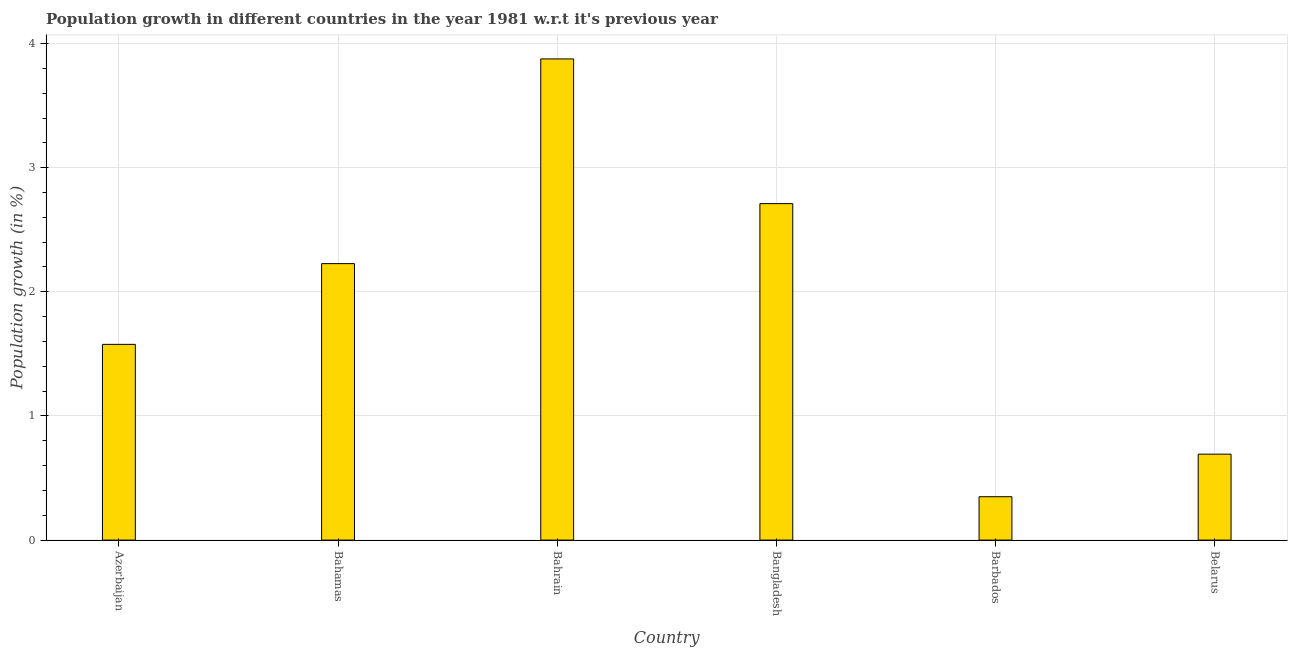Does the graph contain any zero values?
Your answer should be very brief. No. Does the graph contain grids?
Your answer should be very brief. Yes. What is the title of the graph?
Provide a succinct answer. Population growth in different countries in the year 1981 w.r.t it's previous year. What is the label or title of the Y-axis?
Provide a succinct answer. Population growth (in %). What is the population growth in Bahrain?
Your response must be concise. 3.88. Across all countries, what is the maximum population growth?
Provide a short and direct response. 3.88. Across all countries, what is the minimum population growth?
Provide a short and direct response. 0.35. In which country was the population growth maximum?
Your answer should be compact. Bahrain. In which country was the population growth minimum?
Offer a terse response. Barbados. What is the sum of the population growth?
Offer a terse response. 11.43. What is the difference between the population growth in Bahrain and Barbados?
Make the answer very short. 3.53. What is the average population growth per country?
Give a very brief answer. 1.91. What is the median population growth?
Offer a terse response. 1.9. What is the ratio of the population growth in Azerbaijan to that in Bahrain?
Ensure brevity in your answer.  0.41. What is the difference between the highest and the second highest population growth?
Provide a short and direct response. 1.17. Is the sum of the population growth in Azerbaijan and Bahrain greater than the maximum population growth across all countries?
Your answer should be very brief. Yes. What is the difference between the highest and the lowest population growth?
Your response must be concise. 3.53. Are all the bars in the graph horizontal?
Ensure brevity in your answer.  No. What is the Population growth (in %) in Azerbaijan?
Provide a succinct answer. 1.58. What is the Population growth (in %) in Bahamas?
Keep it short and to the point. 2.23. What is the Population growth (in %) of Bahrain?
Offer a terse response. 3.88. What is the Population growth (in %) in Bangladesh?
Keep it short and to the point. 2.71. What is the Population growth (in %) in Barbados?
Provide a short and direct response. 0.35. What is the Population growth (in %) in Belarus?
Provide a short and direct response. 0.69. What is the difference between the Population growth (in %) in Azerbaijan and Bahamas?
Keep it short and to the point. -0.65. What is the difference between the Population growth (in %) in Azerbaijan and Bahrain?
Your answer should be very brief. -2.3. What is the difference between the Population growth (in %) in Azerbaijan and Bangladesh?
Provide a succinct answer. -1.13. What is the difference between the Population growth (in %) in Azerbaijan and Barbados?
Keep it short and to the point. 1.23. What is the difference between the Population growth (in %) in Azerbaijan and Belarus?
Make the answer very short. 0.88. What is the difference between the Population growth (in %) in Bahamas and Bahrain?
Your response must be concise. -1.65. What is the difference between the Population growth (in %) in Bahamas and Bangladesh?
Offer a very short reply. -0.48. What is the difference between the Population growth (in %) in Bahamas and Barbados?
Offer a very short reply. 1.88. What is the difference between the Population growth (in %) in Bahamas and Belarus?
Make the answer very short. 1.53. What is the difference between the Population growth (in %) in Bahrain and Bangladesh?
Keep it short and to the point. 1.17. What is the difference between the Population growth (in %) in Bahrain and Barbados?
Offer a terse response. 3.53. What is the difference between the Population growth (in %) in Bahrain and Belarus?
Make the answer very short. 3.18. What is the difference between the Population growth (in %) in Bangladesh and Barbados?
Your answer should be compact. 2.36. What is the difference between the Population growth (in %) in Bangladesh and Belarus?
Provide a short and direct response. 2.02. What is the difference between the Population growth (in %) in Barbados and Belarus?
Ensure brevity in your answer.  -0.34. What is the ratio of the Population growth (in %) in Azerbaijan to that in Bahamas?
Give a very brief answer. 0.71. What is the ratio of the Population growth (in %) in Azerbaijan to that in Bahrain?
Make the answer very short. 0.41. What is the ratio of the Population growth (in %) in Azerbaijan to that in Bangladesh?
Make the answer very short. 0.58. What is the ratio of the Population growth (in %) in Azerbaijan to that in Barbados?
Keep it short and to the point. 4.51. What is the ratio of the Population growth (in %) in Azerbaijan to that in Belarus?
Ensure brevity in your answer.  2.28. What is the ratio of the Population growth (in %) in Bahamas to that in Bahrain?
Keep it short and to the point. 0.57. What is the ratio of the Population growth (in %) in Bahamas to that in Bangladesh?
Your answer should be compact. 0.82. What is the ratio of the Population growth (in %) in Bahamas to that in Barbados?
Provide a short and direct response. 6.37. What is the ratio of the Population growth (in %) in Bahamas to that in Belarus?
Offer a very short reply. 3.22. What is the ratio of the Population growth (in %) in Bahrain to that in Bangladesh?
Provide a succinct answer. 1.43. What is the ratio of the Population growth (in %) in Bahrain to that in Barbados?
Offer a very short reply. 11.09. What is the ratio of the Population growth (in %) in Bahrain to that in Belarus?
Provide a short and direct response. 5.6. What is the ratio of the Population growth (in %) in Bangladesh to that in Barbados?
Make the answer very short. 7.75. What is the ratio of the Population growth (in %) in Bangladesh to that in Belarus?
Keep it short and to the point. 3.91. What is the ratio of the Population growth (in %) in Barbados to that in Belarus?
Your answer should be compact. 0.51. 